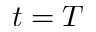Convert formula to latex. <formula><loc_0><loc_0><loc_500><loc_500>t = T</formula> 